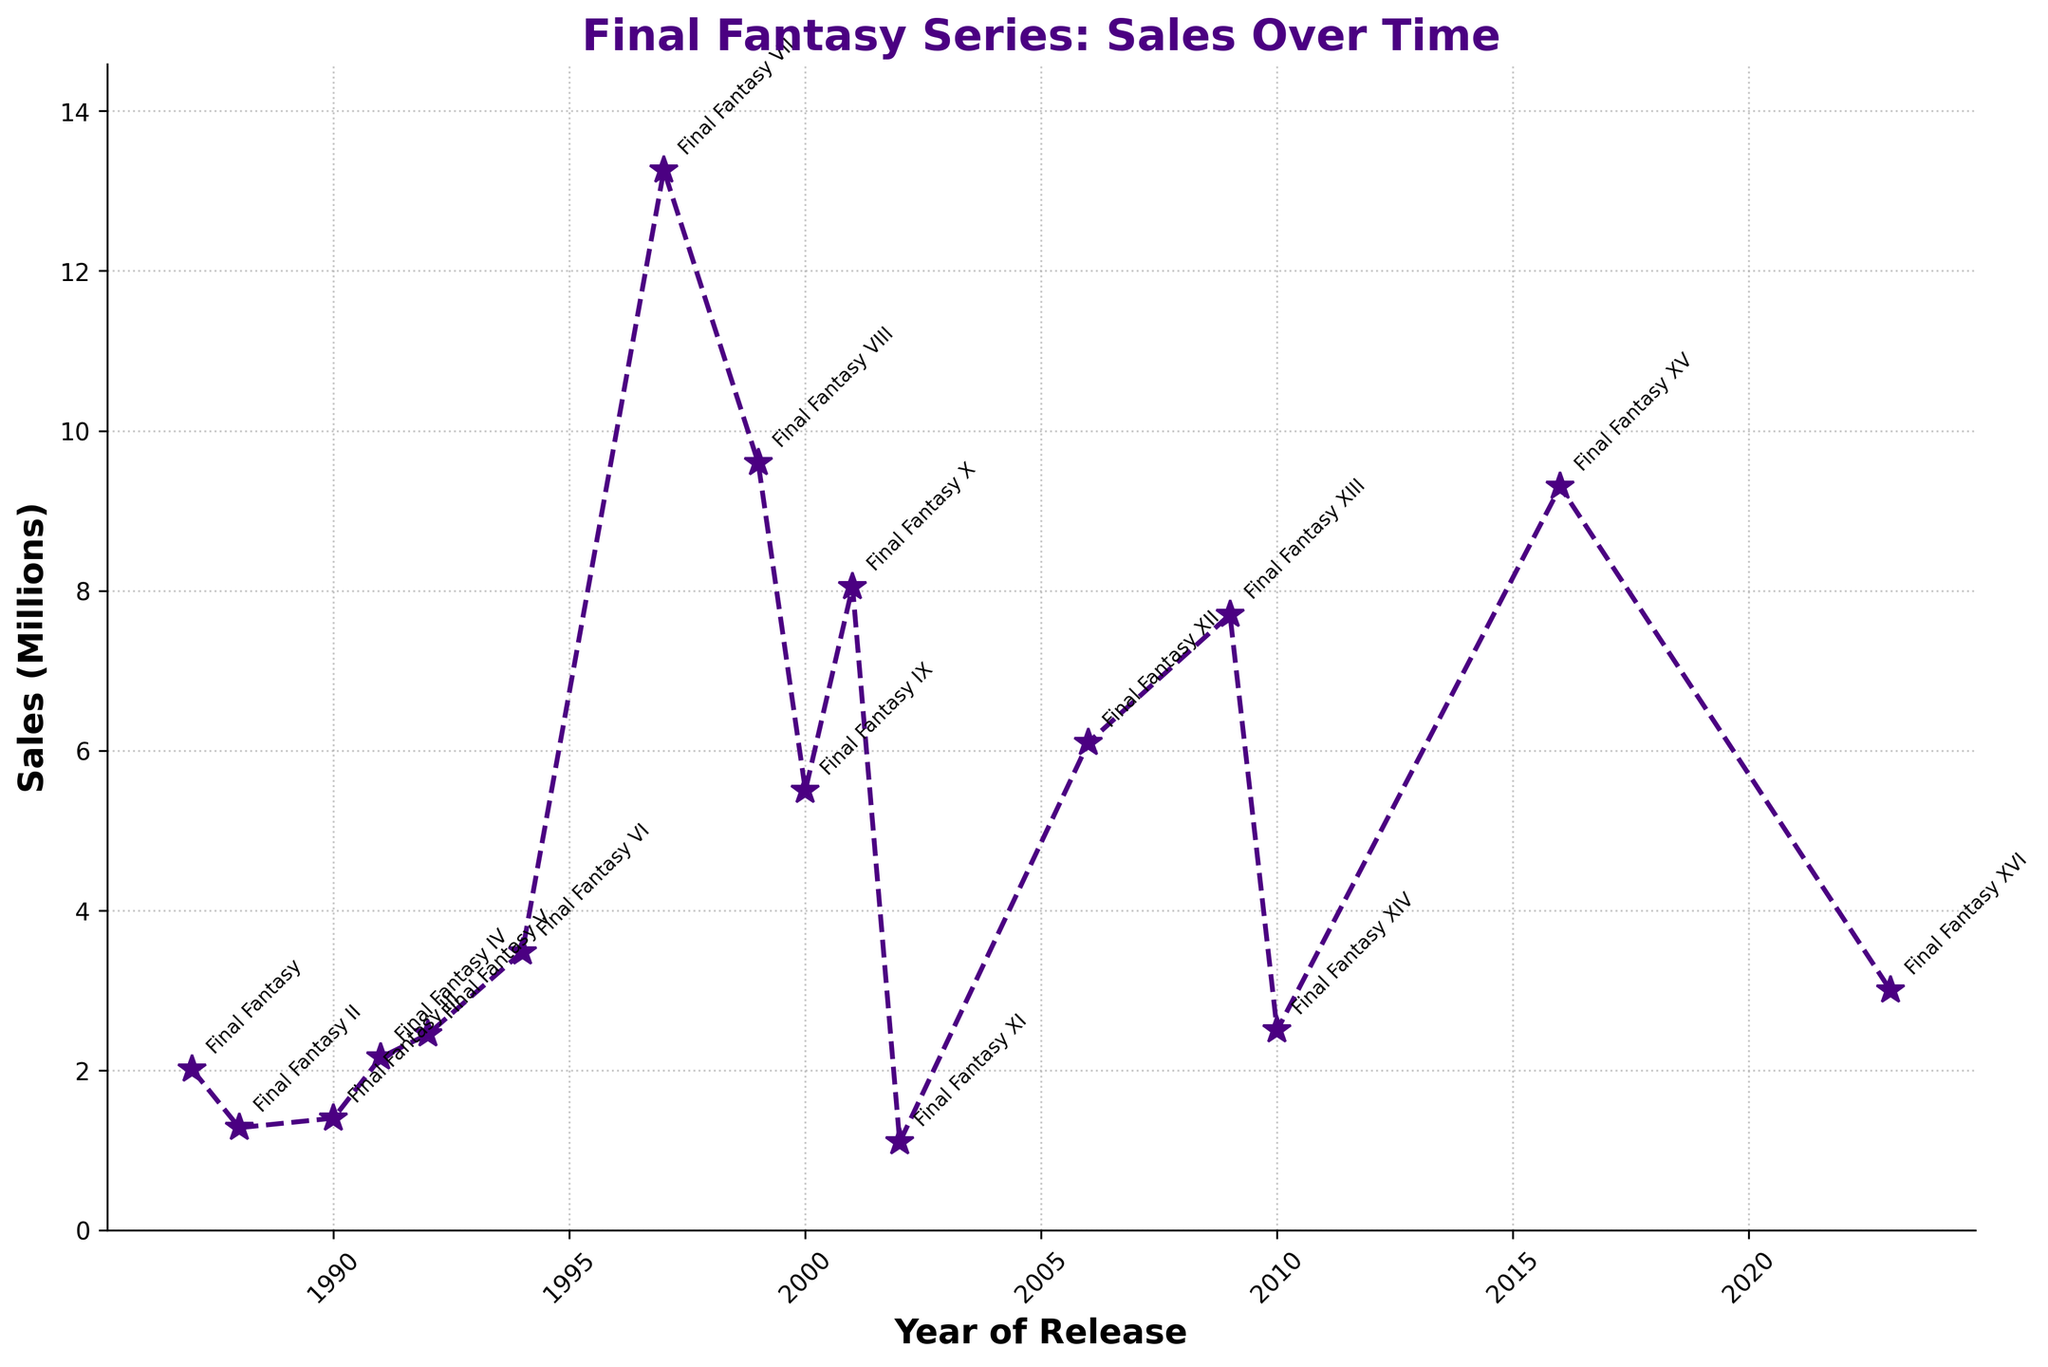What is the title of the game that achieved the highest sales? To determine this, look at the sales figures on the Y-axis and find the corresponding title. The highest point on the line plot corresponds to "Final Fantasy VII".
Answer: Final Fantasy VII Which game had a higher sales figure, Final Fantasy IX or Final Fantasy X? Check the Y-axis values for both Final Fantasy IX and X. Final Fantasy IX had sales of 5.50 million, while X had 8.05 million. X is higher than IX.
Answer: Final Fantasy X By how much did the sales for Final Fantasy VIII drop compared to Final Fantasy VII? Find the sales figures for both titles: Final Fantasy VII had 13.26 million, and Final Fantasy VIII had 9.60 million. Subtract VIII sales from VII: 13.26 - 9.60 = 3.66 million.
Answer: 3.66 million Which Final Fantasy game showed the largest increase in sales compared to its immediate predecessor? Look at the differences between consecutive games. The largest jump is between Final Fantasy VI (3.48 million) and Final Fantasy VII (13.26 million), an increase of 13.26 - 3.48 = 9.78 million.
Answer: Final Fantasy VII What is the average sales figure for the first five Final Fantasy games? Sum the sales figures of the first five games and divide by 5: (2.01 + 1.28 + 1.40 + 2.16 + 2.45) / 5. This calculation yields (9.30 / 5) = 1.86 million.
Answer: 1.86 million Between which two consecutive games did the sales drop the most? Compare the sales figures of consecutive games: The biggest drop is between Final Fantasy VIII (9.60 million) and Final Fantasy IX (5.50 million). The difference is 9.60 - 5.50 = 4.10 million.
Answer: Between Final Fantasy VIII and Final Fantasy IX How many mainline Final Fantasy games sold over 5 million copies? Identify from the chart games that have sales above 5 million: FFVII, FFVIII, FFIX, FFX, FFXII, and FFXV. Count them to find there are 6 such games.
Answer: 6 games Which game had the lowest sales, and what was its sales figure? Look for the lowest point on the Y-axis, which corresponds to Final Fantasy XI with sales of 1.10 million.
Answer: Final Fantasy XI What is the combined sales figure for the Final Fantasy games released in the 1990s? Sum the sales of games released in the 1990s: FFIII (1.40), FFIV (2.16), FFV (2.45), FFVI (3.48), FFVII (13.26), FFVIII (9.60), FFIX (5.50). This gives (2.16 + 2.45 + 3.48 + 13.26 + 9.60 + 5.50) = 36.45 million.
Answer: 36.45 million Which two games released in the 2000s have the smallest sales difference between them? Compare sales figures for games released in the 2000s: FFX (8.05), FFXI (1.10), FFXII (6.10), FFXIII (7.70), FFXIV (2.50). The smallest difference is between FFXIII (7.70) and FFXII (6.10), which is 7.70 - 6.10 = 1.60 million.
Answer: Final Fantasy XII and Final Fantasy XIII 